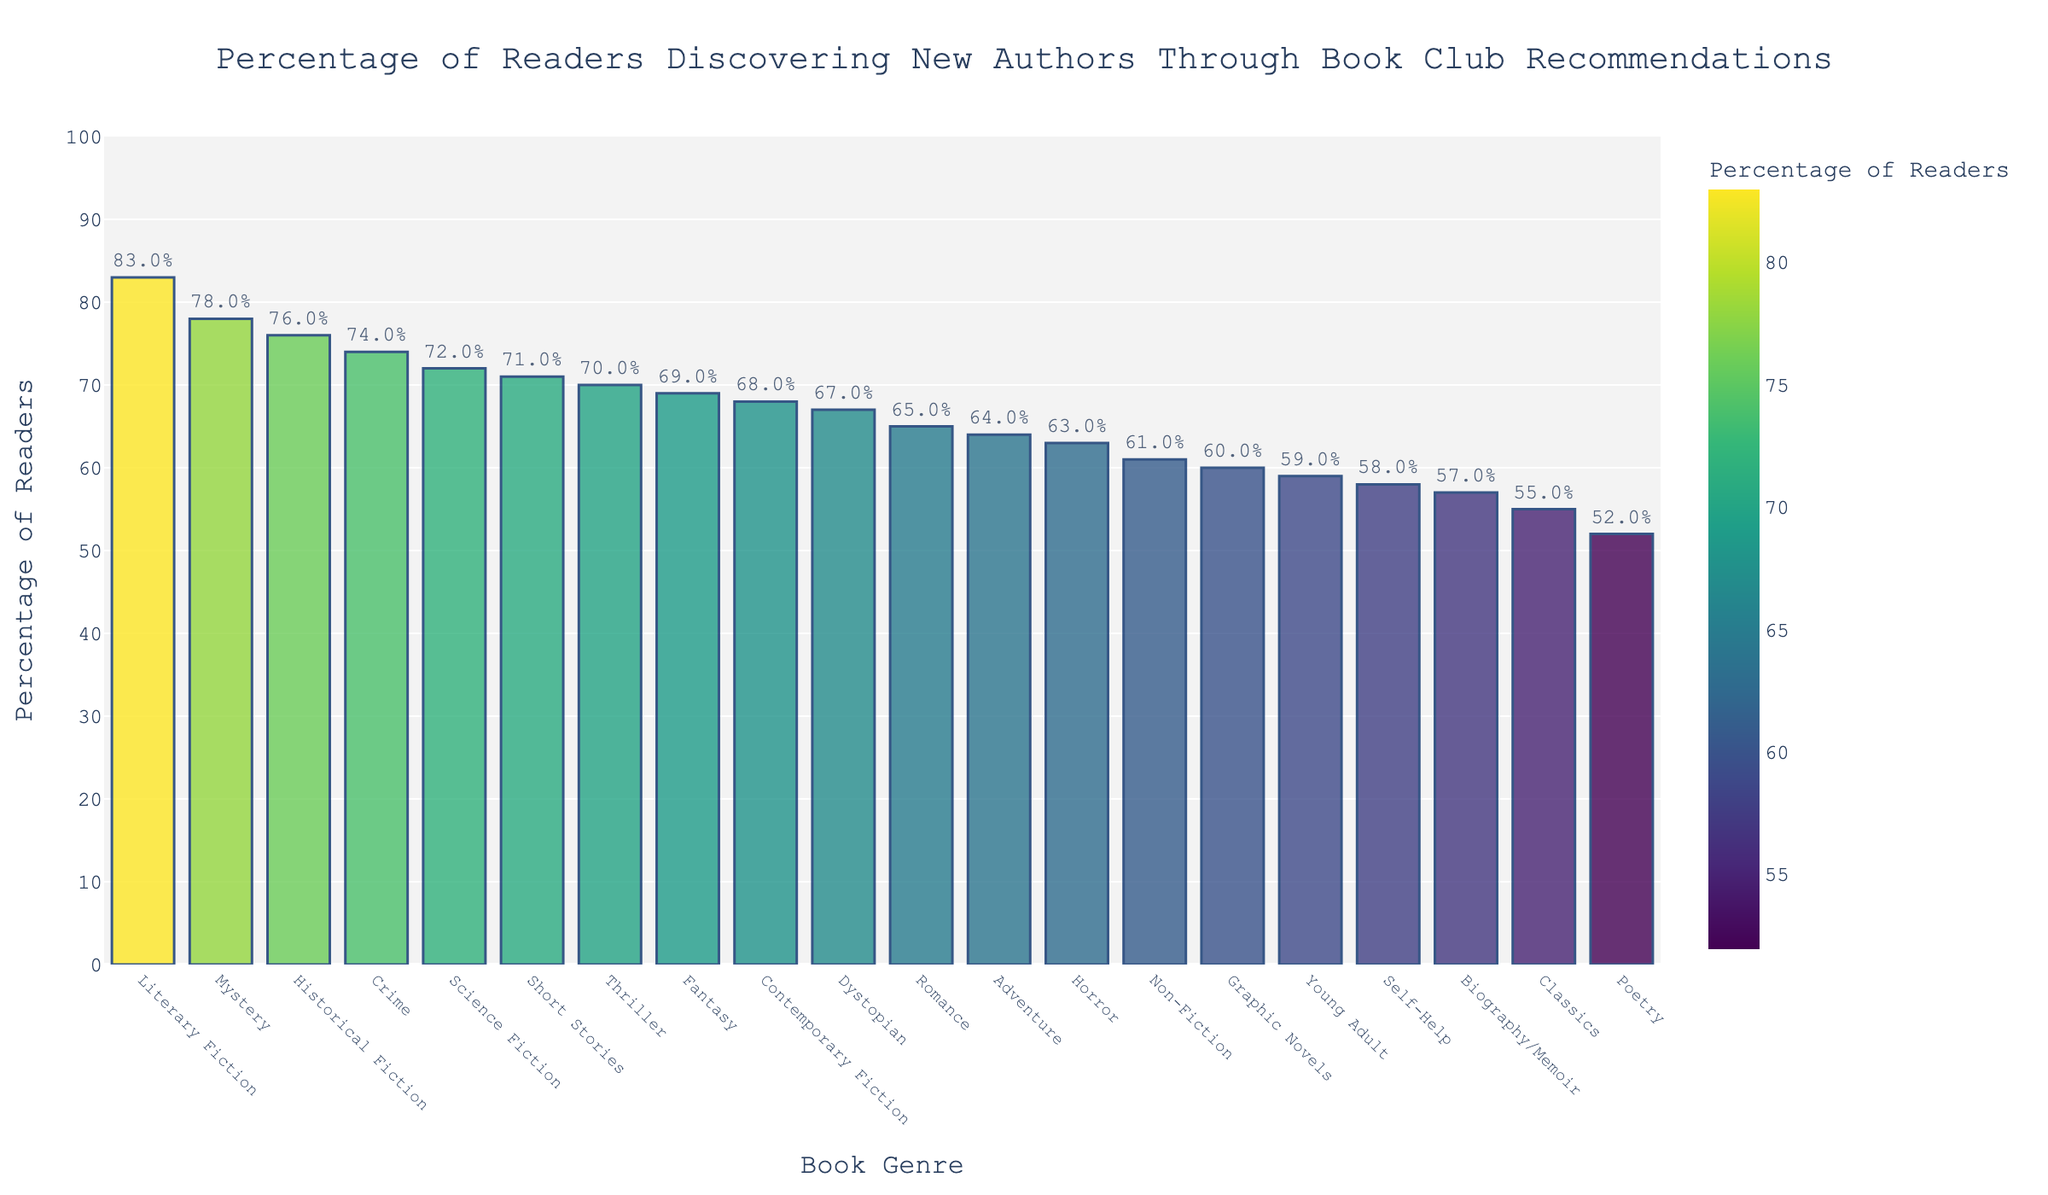Which genre has the highest percentage of readers discovering new authors through book club recommendations? Look at the highest bar in the chart to identify the genre with the highest percentage.
Answer: Literary Fiction Which genre has the lowest percentage of readers discovering new authors through book club recommendations? Look at the shortest bar in the chart to identify the genre with the lowest percentage.
Answer: Poetry How much higher is the percentage for Mystery compared to Non-Fiction? Find the percentage for Mystery (78) and Non-Fiction (61), and calculate the difference (78 - 61).
Answer: 17 What is the average percentage of readers discovering new authors for the genres Romance, Science Fiction, and Fantasy? Add the percentages for Romance (65), Science Fiction (72), and Fantasy (69) and divide by 3 to find the average ((65 + 72 + 69) / 3).
Answer: 68.67 Between Thrillers and Crime, which genre has a higher percentage, and by how much? Compare the percentages for Thrillers (70) and Crime (74), and find the difference (74 - 70).
Answer: Crime by 4 Which genre's bar color is the darkest, and what might that imply about the percentage? The color scale indicates that the darkest color correlates with the highest percentage. Identify the darkest bar visually, which supports the highest percentage.
Answer: Literary Fiction What is the median percentage for the listed genres? List all percentages in ascending order and find the middle value: (52, 55, 57, 58, 59, 60, 61, 63, 64, 65, 67, 68, 69, 70, 71, 72, 74, 76, 78, 83). The median is the average of the 10th and 11th values ((65+67)/2).
Answer: 66 Are there any genres where the percentage of readers discovering new authors is between 60% and 70%? Identify all bars within the 60-70% range by looking at their heights and associated percentages: Non-Fiction (61), Horror (63), Self-Help (58), Adventure (64), Romance (65), Poetry (52), Thrillers (70), Fantasy (69), Contemporary Fiction (68), and Dystopian (67).
Answer: Yes Does the color intensity change linearly with the percentage of readers discovering new authors, and how can you tell? Evaluate the gradation of colors from lighter to darker across the percentages. Confirm if the darkest bars correspond to the highest percentages and lighter to lower percentages.
Answer: Yes How many genres have a percentage of over 70% of readers discovering new authors? Count all the bars that represent percentages over 70%: Mystery (78), Science Fiction (72), Literary Fiction (83), Historical Fiction (76), Thriller (70), Crime (74), Short Stories (71).
Answer: 7 